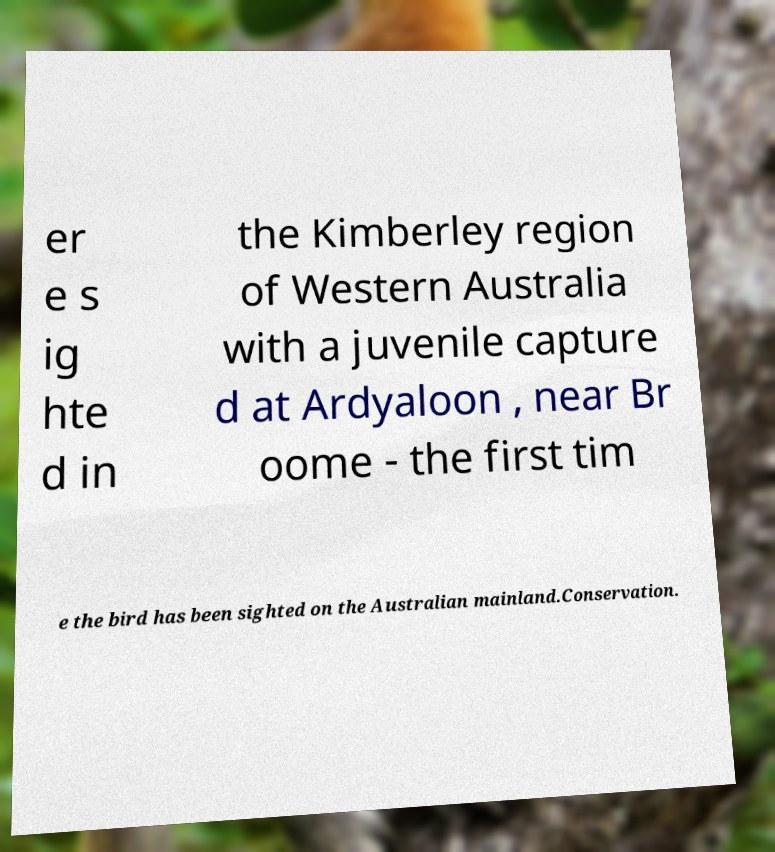Can you accurately transcribe the text from the provided image for me? er e s ig hte d in the Kimberley region of Western Australia with a juvenile capture d at Ardyaloon , near Br oome - the first tim e the bird has been sighted on the Australian mainland.Conservation. 